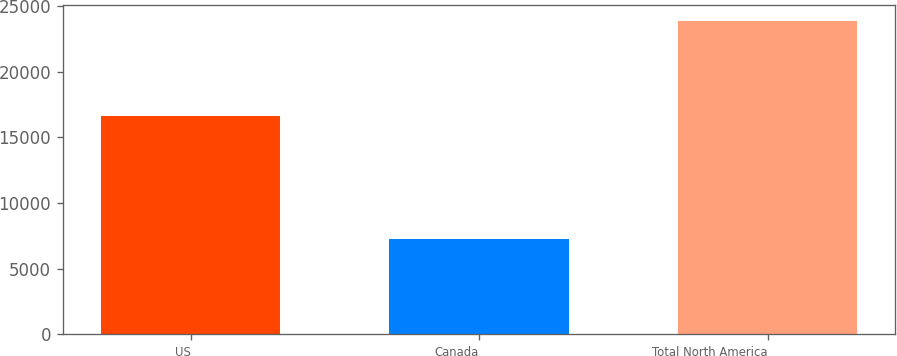<chart> <loc_0><loc_0><loc_500><loc_500><bar_chart><fcel>US<fcel>Canada<fcel>Total North America<nl><fcel>16616<fcel>7280<fcel>23896<nl></chart> 